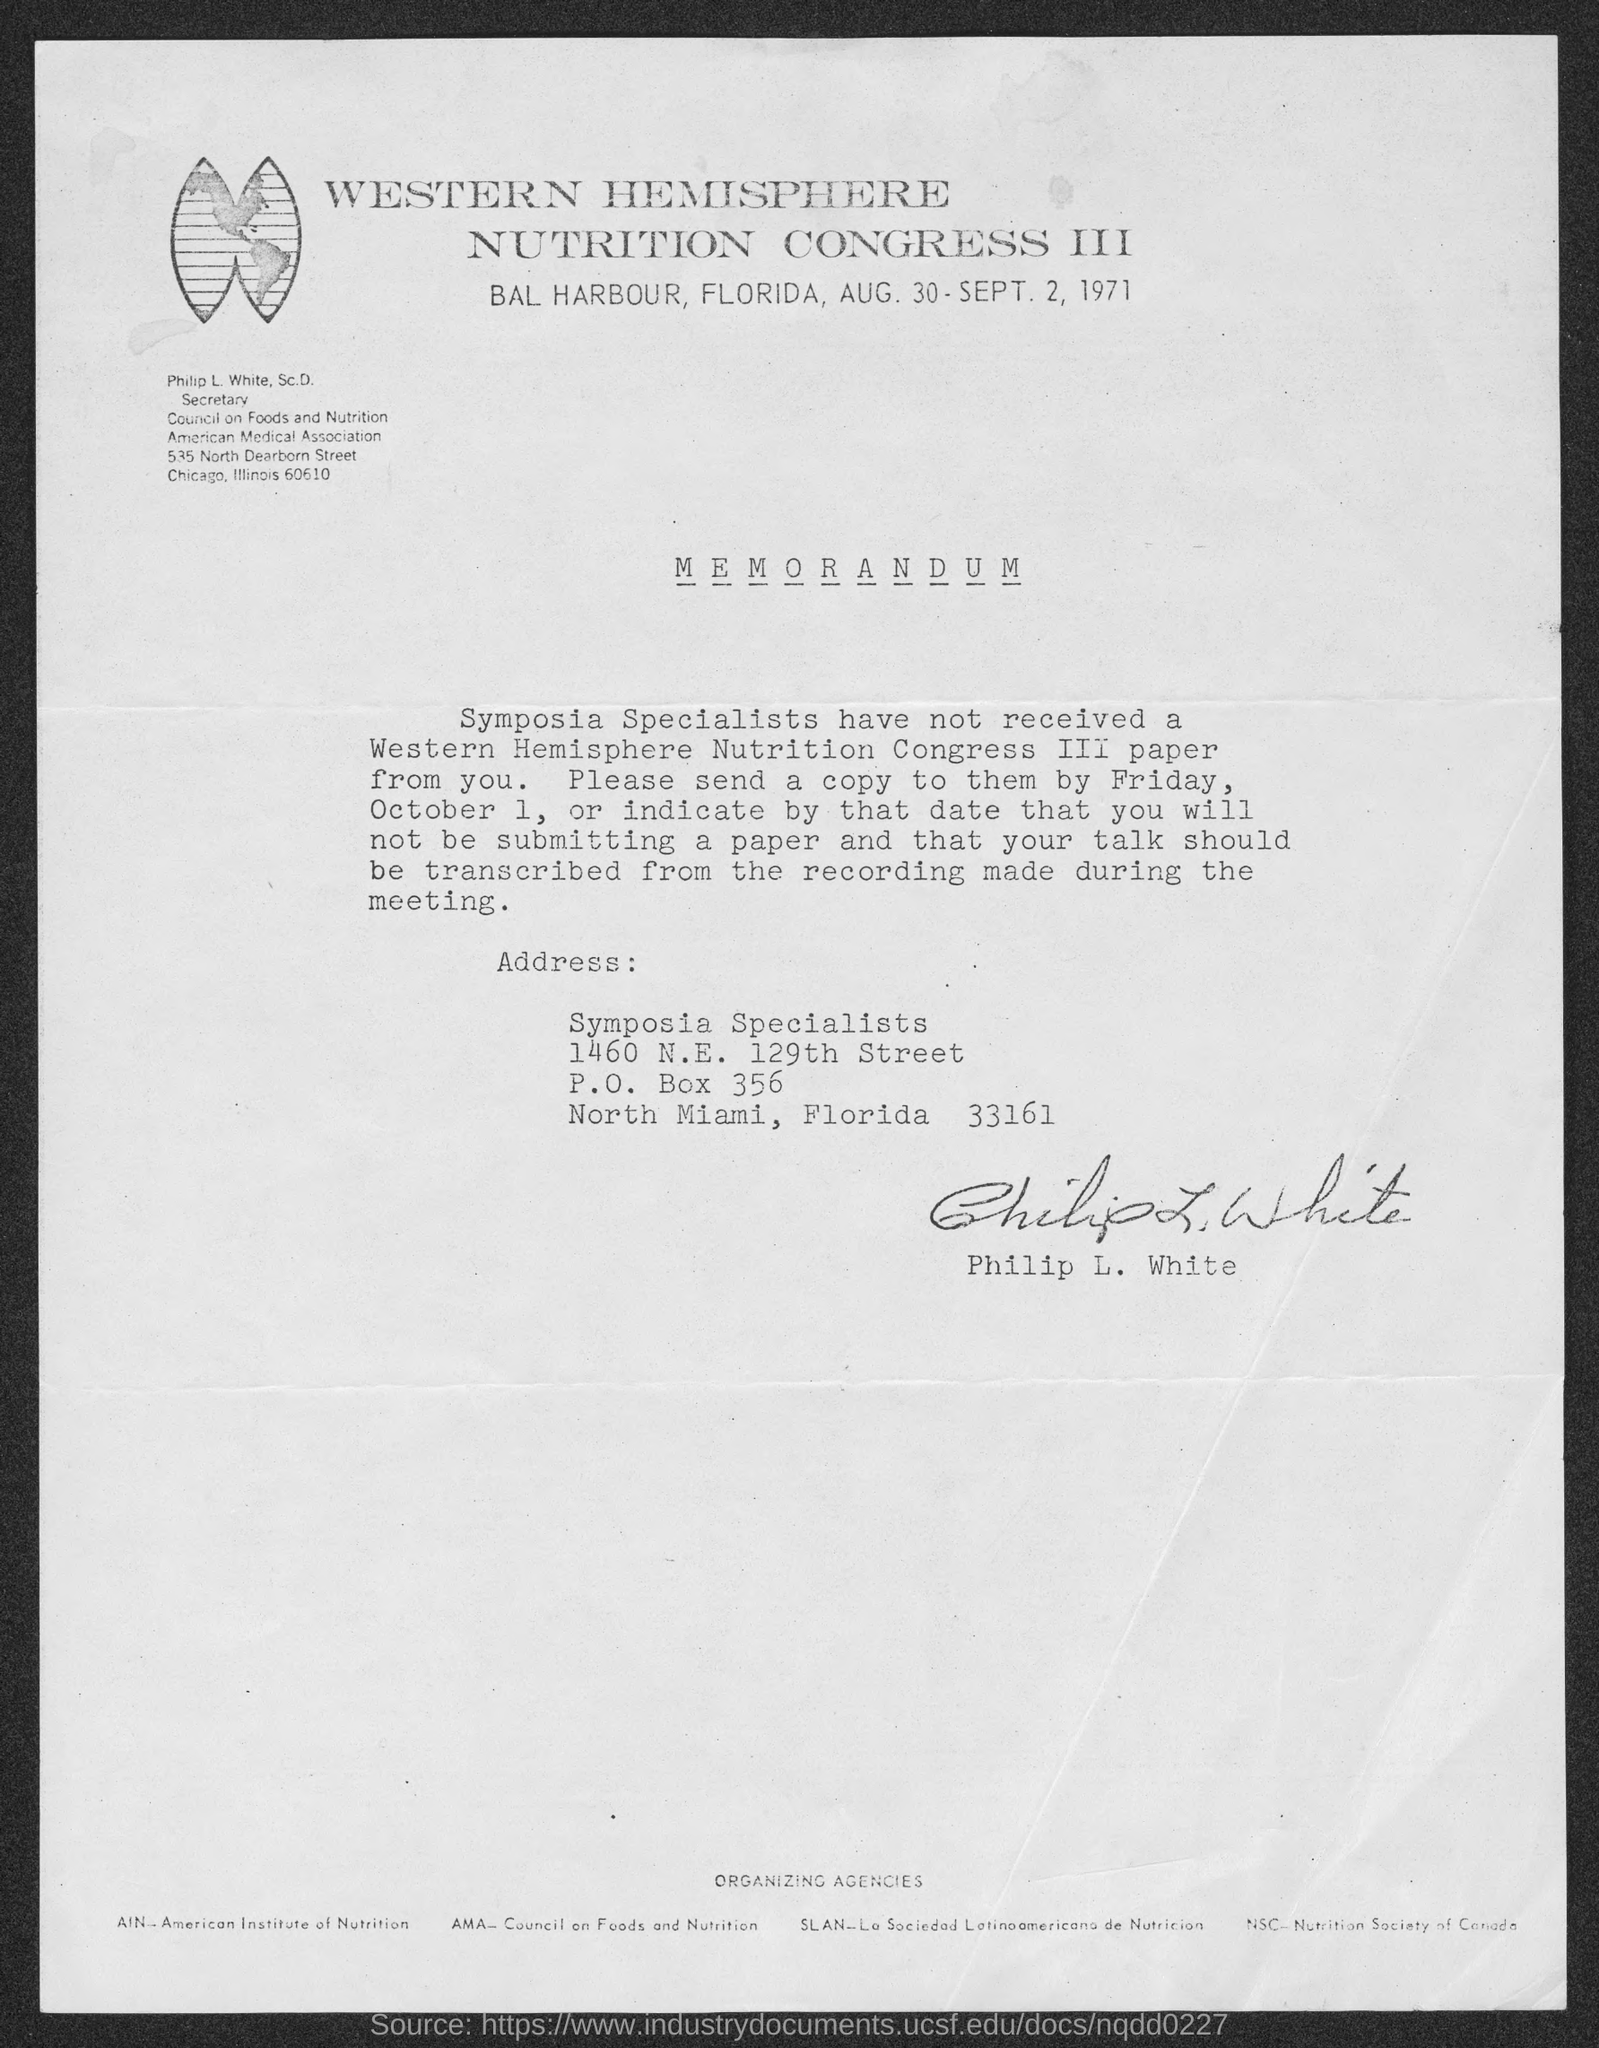Outline some significant characteristics in this image. The memorandum has been signed by Philip L. White. Philip L. White, Sc.D., holds the designation of Secretary of the Council on Foods and Nutrition. 